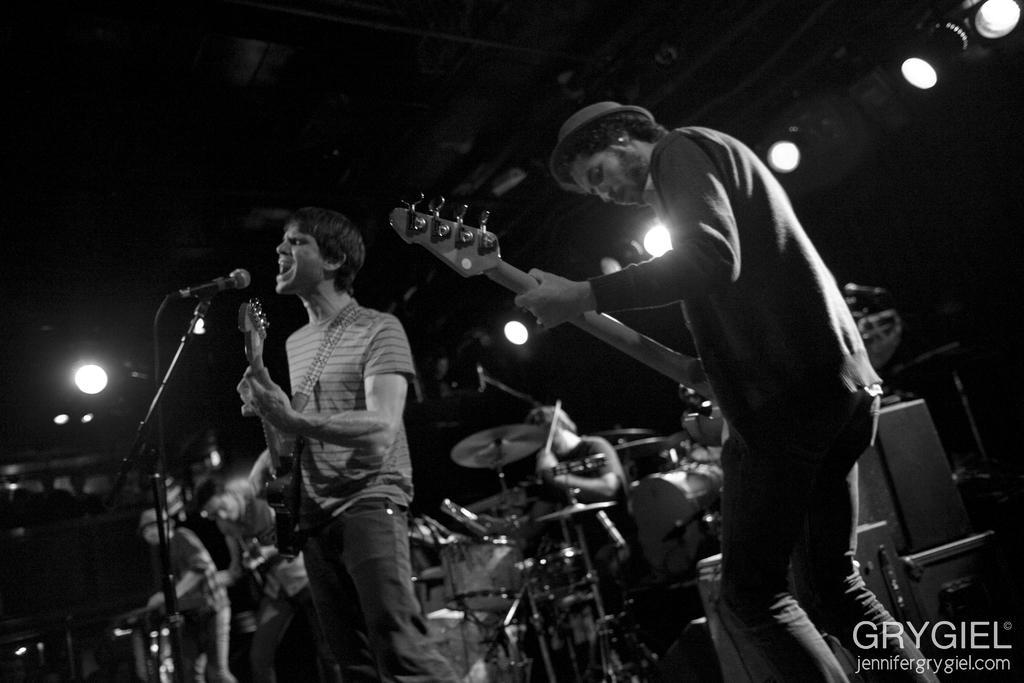Please provide a concise description of this image. There are few people on the stage performing by playing musical instruments and here a person is playing guitar and singing on mic. In the background there are lights. 